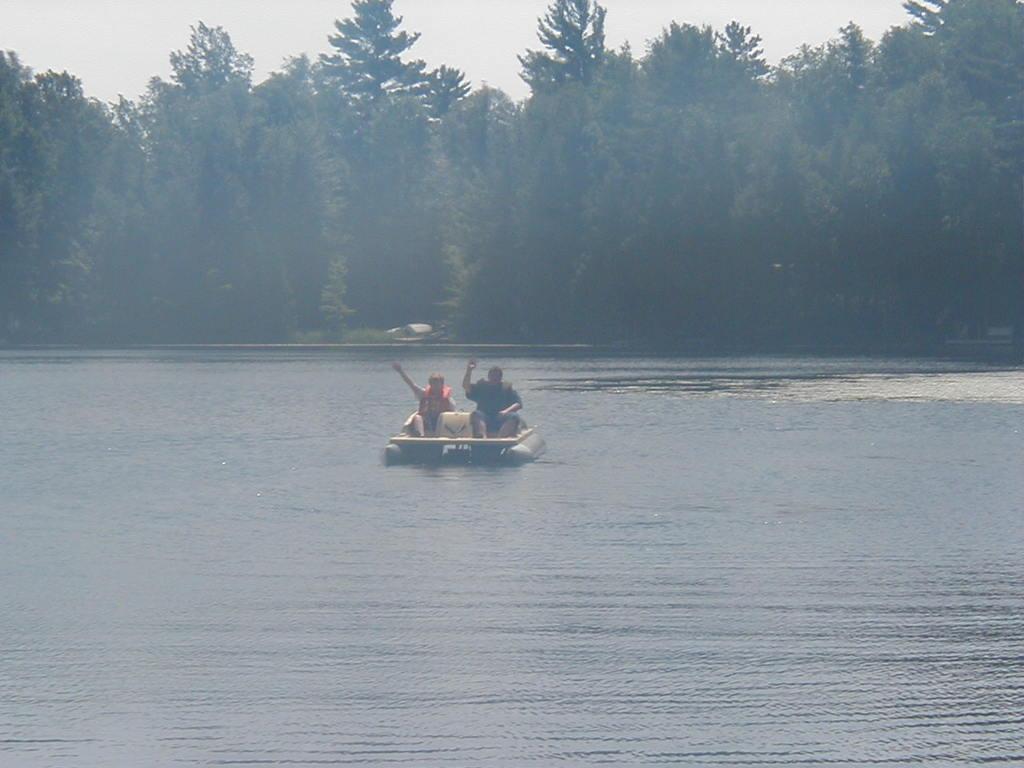How would you summarize this image in a sentence or two? At the bottom of the image I can see a river. There are two persons sitting on the boat. In the background there are many trees. At the top of the image I can see the sky. 